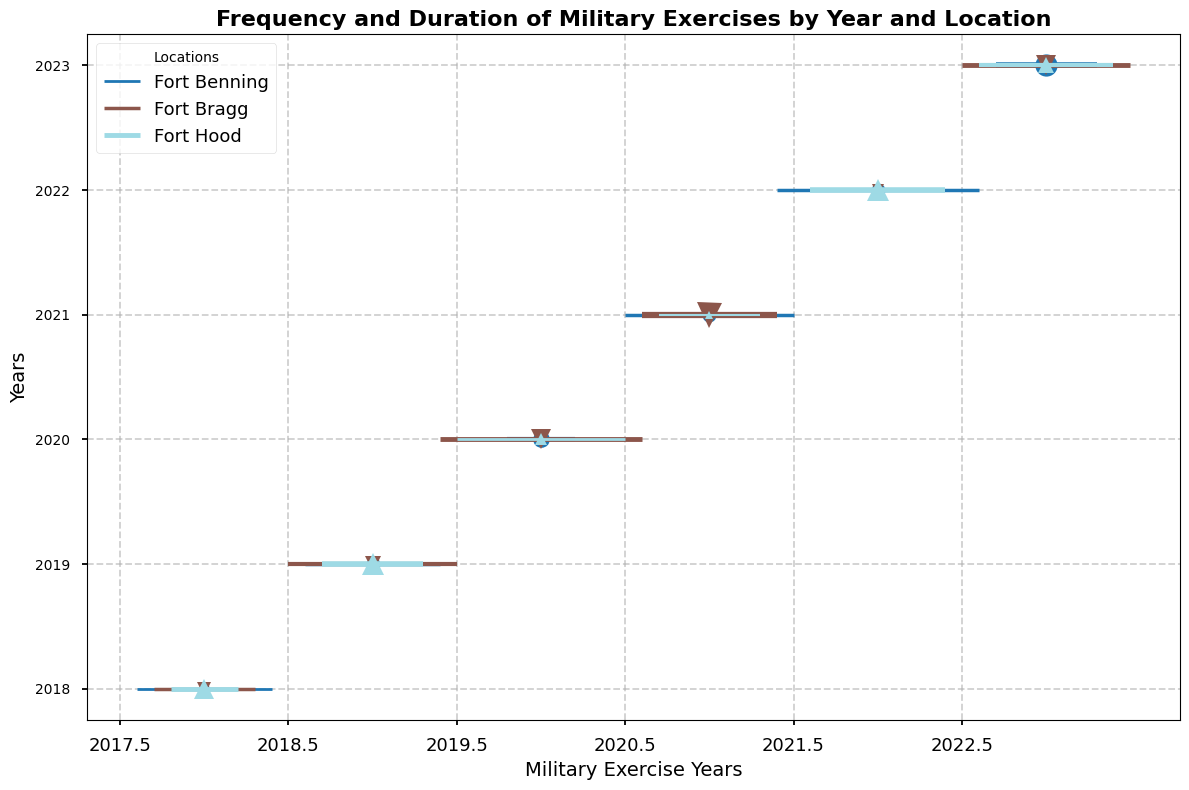What year had the highest frequency of military exercises at Fort Bragg? To determine the year with the highest frequency at Fort Bragg, observe the thickness and ends of lines corresponding to Fort Bragg's colors. The highest frequency will be the one with lines most stretched on the horizontal axis.
Answer: 2020 Which location had the longest duration of exercises in 2021? Examine the thickness of the lines in 2021 for each location. The greatest thickness will indicate the longest duration.
Answer: Fort Bragg Compare the frequency of exercises between 2019 and 2023 at Fort Bragg. Which year has a higher frequency, and by how much? Look at the lines for Fort Bragg in 2019 and 2023 and measure the horizontal span in terms of ticks (frequency). Calculate the difference.
Answer: 2023; by 2 In which year did Fort Benning have exercises more frequently: 2018 or 2022? Compare the horizontal span of lines (frequency) for Fort Benning between 2018 and 2022. The longer span indicates more frequency.
Answer: 2022 What is the average duration of exercises held in 2020 at Fort Hood? Find the duration (thickness of the line) for the exercises at Fort Hood in 2020, sum them up, and then divide by the number of exercises. There is one exercise with a duration of 4 days and another with 4 days. Average is (4 + 4)/1 = 4.
Answer: 4 Which exercise in 2023 had the highest duration at Fort Benning? Identify all the exercises in 2023 for Fort Benning and observe the thickest line to determine the maximum duration.
Answer: Exercise Romeo Compare the visual markers in the years 2020 and 2021 for Fort Hood. Which year has bigger markers, and what does this indicate? The size of the markers is proportional to the duration. Observe the size difference of circles for Fort Hood in 2020 and 2021, indicating the year with longer average durations.
Answer: 2020 In 2019, how does the frequency of exercises at Fort Hood compare to those at Fort Bragg? Look at the length of the lines' horizontal spans for Fort Hood and Fort Bragg in 2019. Determine which is longer covering more ticks, indicating higher frequency.
Answer: Fort Bragg What is the median duration of all military exercises at Fort Benning over the five years? List all durations for Fort Benning from 2018 to 2023, order them, and find the median value. Durations are (4, 5, 5, 5, 6, 8). The median of (4, 5, 5, 5, 6, 8) is 5.
Answer: 5 In 2022, which location had the most frequent exercises, and what was the frequency? Observe the lines for all locations in 2022 and compare their horizontal spans. The longest span indicates the highest frequency.
Answer: Fort Benning; 6 